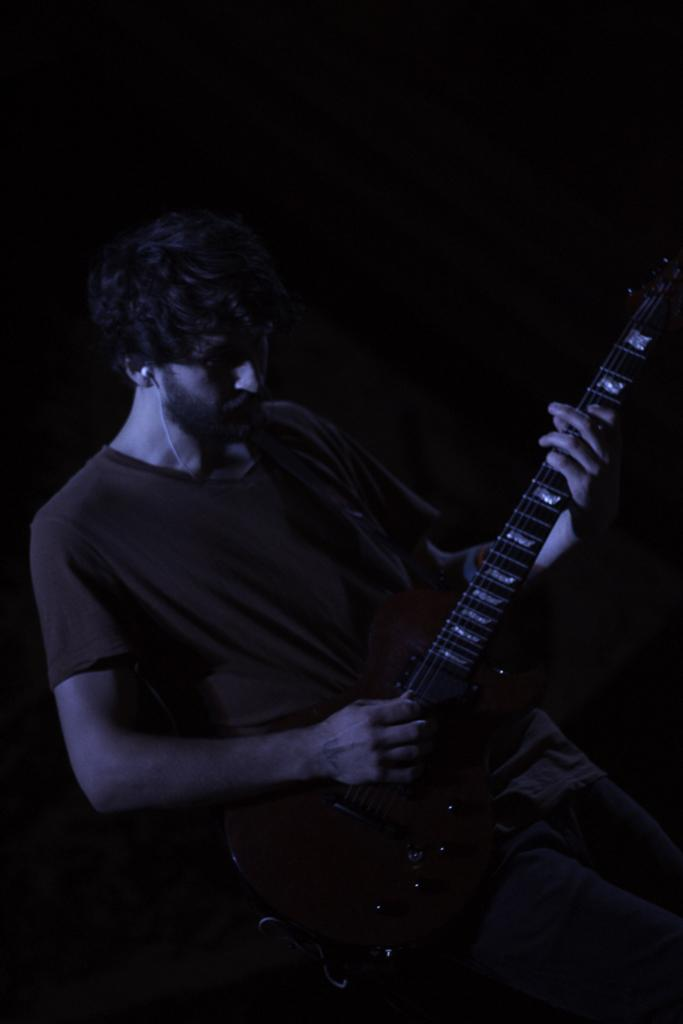What is the man in the image doing? The man is playing a guitar in the image. What type of clothing is the man wearing on his upper body? The man is wearing a t-shirt in the image. What type of clothing is the man wearing on his lower body? The man is wearing jeans in the image. Can you describe any accessories the man is wearing? There is an earphone in one of the man's ears in the image. What type of bread is the man eating while playing the guitar in the image? There is no bread present in the image; the man is playing a guitar and wearing an earphone. 